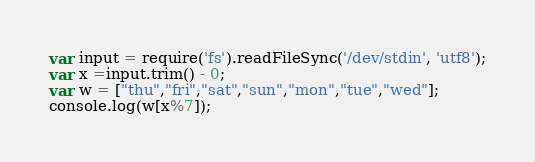Convert code to text. <code><loc_0><loc_0><loc_500><loc_500><_JavaScript_>var input = require('fs').readFileSync('/dev/stdin', 'utf8');
var x =input.trim() - 0;
var w = ["thu","fri","sat","sun","mon","tue","wed"];
console.log(w[x%7]);
</code> 